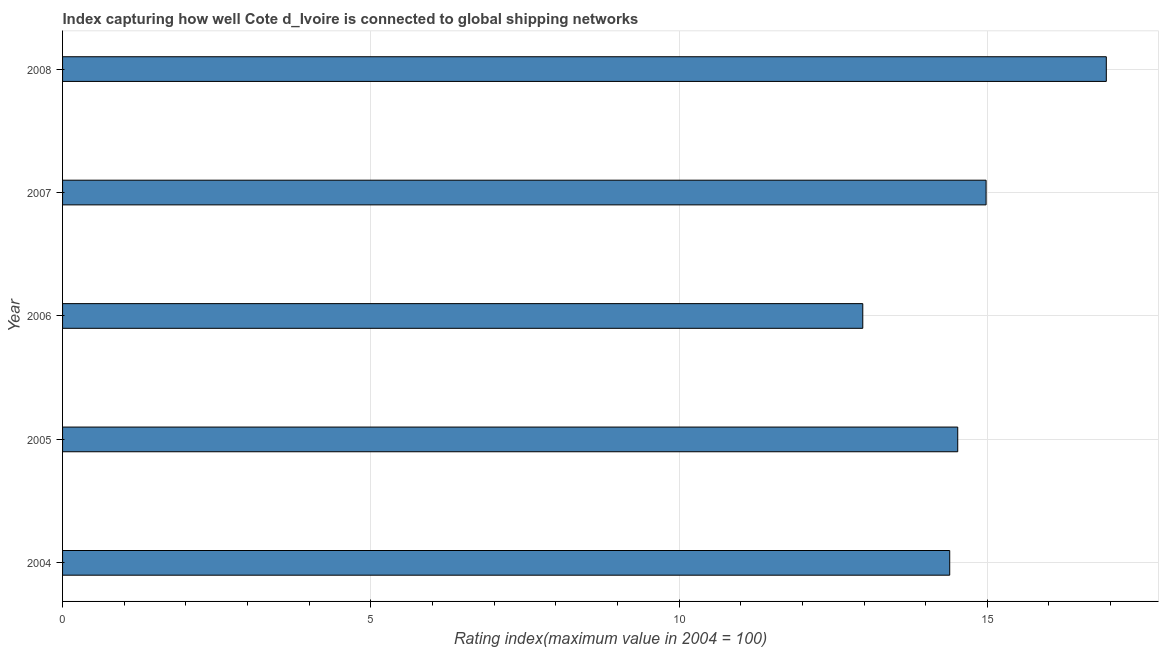Does the graph contain any zero values?
Offer a terse response. No. Does the graph contain grids?
Your response must be concise. Yes. What is the title of the graph?
Offer a terse response. Index capturing how well Cote d_Ivoire is connected to global shipping networks. What is the label or title of the X-axis?
Give a very brief answer. Rating index(maximum value in 2004 = 100). What is the liner shipping connectivity index in 2007?
Make the answer very short. 14.98. Across all years, what is the maximum liner shipping connectivity index?
Give a very brief answer. 16.93. Across all years, what is the minimum liner shipping connectivity index?
Provide a succinct answer. 12.98. What is the sum of the liner shipping connectivity index?
Offer a terse response. 73.8. What is the difference between the liner shipping connectivity index in 2004 and 2007?
Provide a short and direct response. -0.59. What is the average liner shipping connectivity index per year?
Your answer should be very brief. 14.76. What is the median liner shipping connectivity index?
Offer a terse response. 14.52. In how many years, is the liner shipping connectivity index greater than 6 ?
Your response must be concise. 5. What is the ratio of the liner shipping connectivity index in 2005 to that in 2006?
Keep it short and to the point. 1.12. What is the difference between the highest and the second highest liner shipping connectivity index?
Give a very brief answer. 1.95. Is the sum of the liner shipping connectivity index in 2004 and 2008 greater than the maximum liner shipping connectivity index across all years?
Offer a terse response. Yes. What is the difference between the highest and the lowest liner shipping connectivity index?
Provide a short and direct response. 3.95. How many bars are there?
Offer a very short reply. 5. What is the difference between two consecutive major ticks on the X-axis?
Ensure brevity in your answer.  5. What is the Rating index(maximum value in 2004 = 100) of 2004?
Give a very brief answer. 14.39. What is the Rating index(maximum value in 2004 = 100) of 2005?
Your answer should be compact. 14.52. What is the Rating index(maximum value in 2004 = 100) in 2006?
Make the answer very short. 12.98. What is the Rating index(maximum value in 2004 = 100) in 2007?
Provide a succinct answer. 14.98. What is the Rating index(maximum value in 2004 = 100) of 2008?
Your response must be concise. 16.93. What is the difference between the Rating index(maximum value in 2004 = 100) in 2004 and 2005?
Your response must be concise. -0.13. What is the difference between the Rating index(maximum value in 2004 = 100) in 2004 and 2006?
Offer a terse response. 1.41. What is the difference between the Rating index(maximum value in 2004 = 100) in 2004 and 2007?
Offer a terse response. -0.59. What is the difference between the Rating index(maximum value in 2004 = 100) in 2004 and 2008?
Provide a short and direct response. -2.54. What is the difference between the Rating index(maximum value in 2004 = 100) in 2005 and 2006?
Your response must be concise. 1.54. What is the difference between the Rating index(maximum value in 2004 = 100) in 2005 and 2007?
Your answer should be compact. -0.46. What is the difference between the Rating index(maximum value in 2004 = 100) in 2005 and 2008?
Give a very brief answer. -2.41. What is the difference between the Rating index(maximum value in 2004 = 100) in 2006 and 2007?
Your answer should be very brief. -2. What is the difference between the Rating index(maximum value in 2004 = 100) in 2006 and 2008?
Your answer should be compact. -3.95. What is the difference between the Rating index(maximum value in 2004 = 100) in 2007 and 2008?
Offer a terse response. -1.95. What is the ratio of the Rating index(maximum value in 2004 = 100) in 2004 to that in 2006?
Offer a terse response. 1.11. What is the ratio of the Rating index(maximum value in 2004 = 100) in 2004 to that in 2008?
Provide a succinct answer. 0.85. What is the ratio of the Rating index(maximum value in 2004 = 100) in 2005 to that in 2006?
Keep it short and to the point. 1.12. What is the ratio of the Rating index(maximum value in 2004 = 100) in 2005 to that in 2007?
Your response must be concise. 0.97. What is the ratio of the Rating index(maximum value in 2004 = 100) in 2005 to that in 2008?
Give a very brief answer. 0.86. What is the ratio of the Rating index(maximum value in 2004 = 100) in 2006 to that in 2007?
Your answer should be very brief. 0.87. What is the ratio of the Rating index(maximum value in 2004 = 100) in 2006 to that in 2008?
Provide a succinct answer. 0.77. What is the ratio of the Rating index(maximum value in 2004 = 100) in 2007 to that in 2008?
Keep it short and to the point. 0.89. 